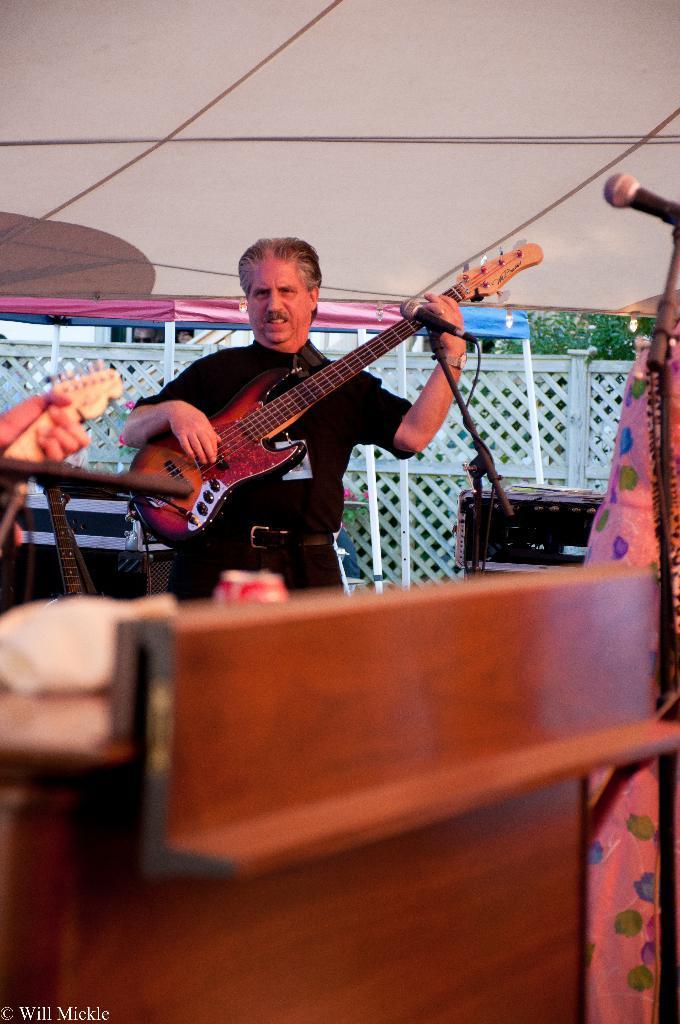In one or two sentences, can you explain what this image depicts? Man in black shirt is holding guitar in his hands and playing it. In front of him, we see microphone. In front of the picture, we see a table on which coke bottle and tissue paper are placed. On top of picture, we see the ceiling of that room. Behind him, we see fencing and trees. 